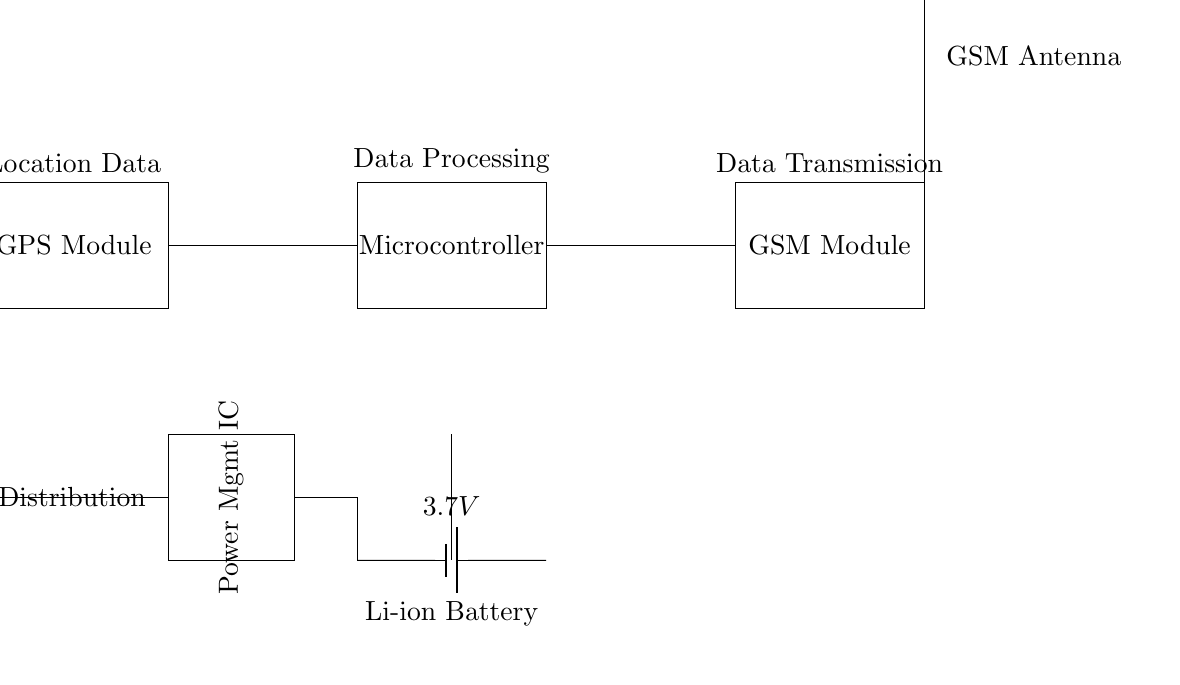What is the main function of the GPS module? The GPS module's main function is to provide location data. It is crucial for tracking the position of neighborhood watch members in real-time.
Answer: location data What is the voltage of the battery used in the circuit? The circuit indicates a battery rated at 3.7 volts, which powers the system during operation.
Answer: 3.7 volts Which component is responsible for data transmission? The component that handles data transmission in this circuit is the GSM module. It communicates the location data to other members.
Answer: GSM module What role does the microcontroller play in the circuit? The microcontroller processes the data received from the GPS module and prepares it for transmission via the GSM module. It's essential for data processing and decision-making in the tracking system.
Answer: data processing How many main components are shown in the circuit? The circuit diagram displays four main components: the GPS module, microcontroller, GSM module, and power management IC. These are integral to the tracking function.
Answer: four What type of power source is used for this circuit? The circuit uses a lithium-ion battery as its power source. This type of battery is common in mobile devices due to its efficiency and size.
Answer: lithium-ion battery What is the purpose of the power management IC? The power management IC regulates and distributes power efficiently to different components in the circuit, ensuring stable operation and extending battery life.
Answer: power regulation 